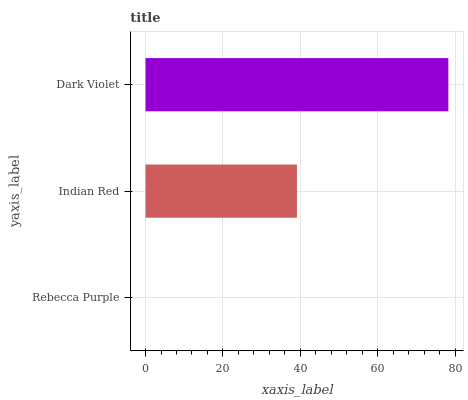Is Rebecca Purple the minimum?
Answer yes or no. Yes. Is Dark Violet the maximum?
Answer yes or no. Yes. Is Indian Red the minimum?
Answer yes or no. No. Is Indian Red the maximum?
Answer yes or no. No. Is Indian Red greater than Rebecca Purple?
Answer yes or no. Yes. Is Rebecca Purple less than Indian Red?
Answer yes or no. Yes. Is Rebecca Purple greater than Indian Red?
Answer yes or no. No. Is Indian Red less than Rebecca Purple?
Answer yes or no. No. Is Indian Red the high median?
Answer yes or no. Yes. Is Indian Red the low median?
Answer yes or no. Yes. Is Dark Violet the high median?
Answer yes or no. No. Is Dark Violet the low median?
Answer yes or no. No. 